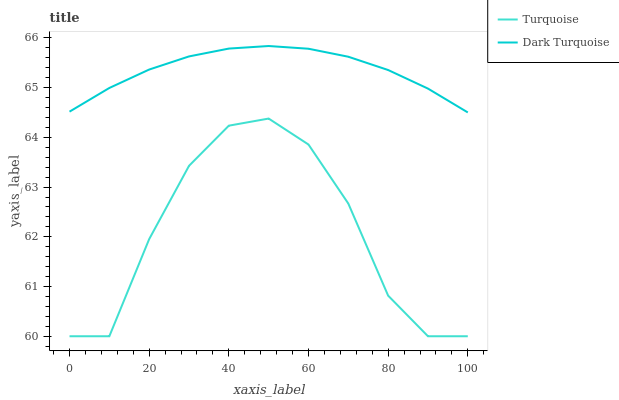Does Turquoise have the minimum area under the curve?
Answer yes or no. Yes. Does Dark Turquoise have the maximum area under the curve?
Answer yes or no. Yes. Does Turquoise have the maximum area under the curve?
Answer yes or no. No. Is Dark Turquoise the smoothest?
Answer yes or no. Yes. Is Turquoise the roughest?
Answer yes or no. Yes. Is Turquoise the smoothest?
Answer yes or no. No. Does Turquoise have the lowest value?
Answer yes or no. Yes. Does Dark Turquoise have the highest value?
Answer yes or no. Yes. Does Turquoise have the highest value?
Answer yes or no. No. Is Turquoise less than Dark Turquoise?
Answer yes or no. Yes. Is Dark Turquoise greater than Turquoise?
Answer yes or no. Yes. Does Turquoise intersect Dark Turquoise?
Answer yes or no. No. 